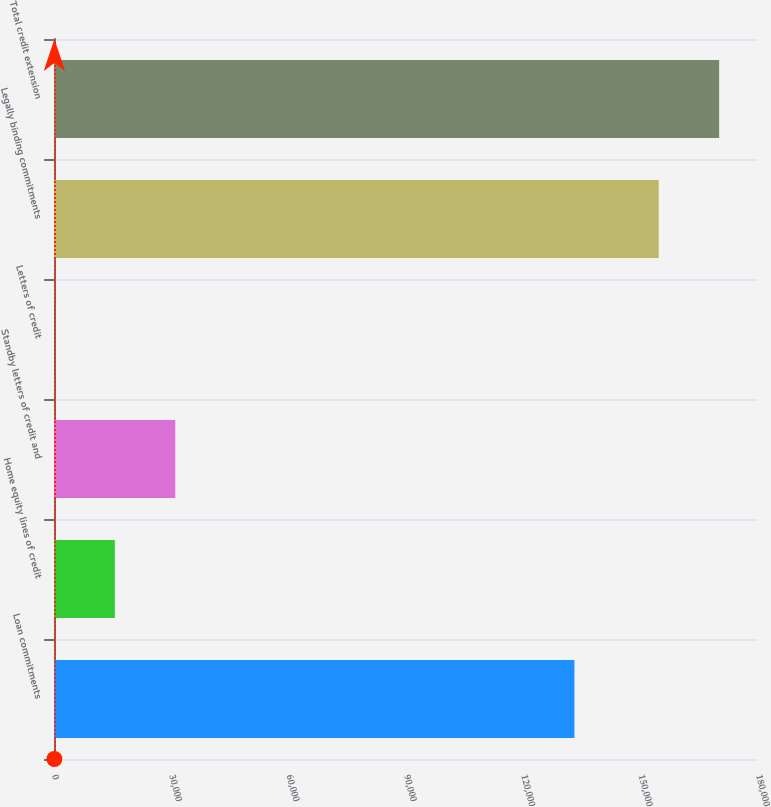Convert chart to OTSL. <chart><loc_0><loc_0><loc_500><loc_500><bar_chart><fcel>Loan commitments<fcel>Home equity lines of credit<fcel>Standby letters of credit and<fcel>Letters of credit<fcel>Legally binding commitments<fcel>Total credit extension<nl><fcel>133063<fcel>15554.8<fcel>31006.6<fcel>103<fcel>154621<fcel>170073<nl></chart> 